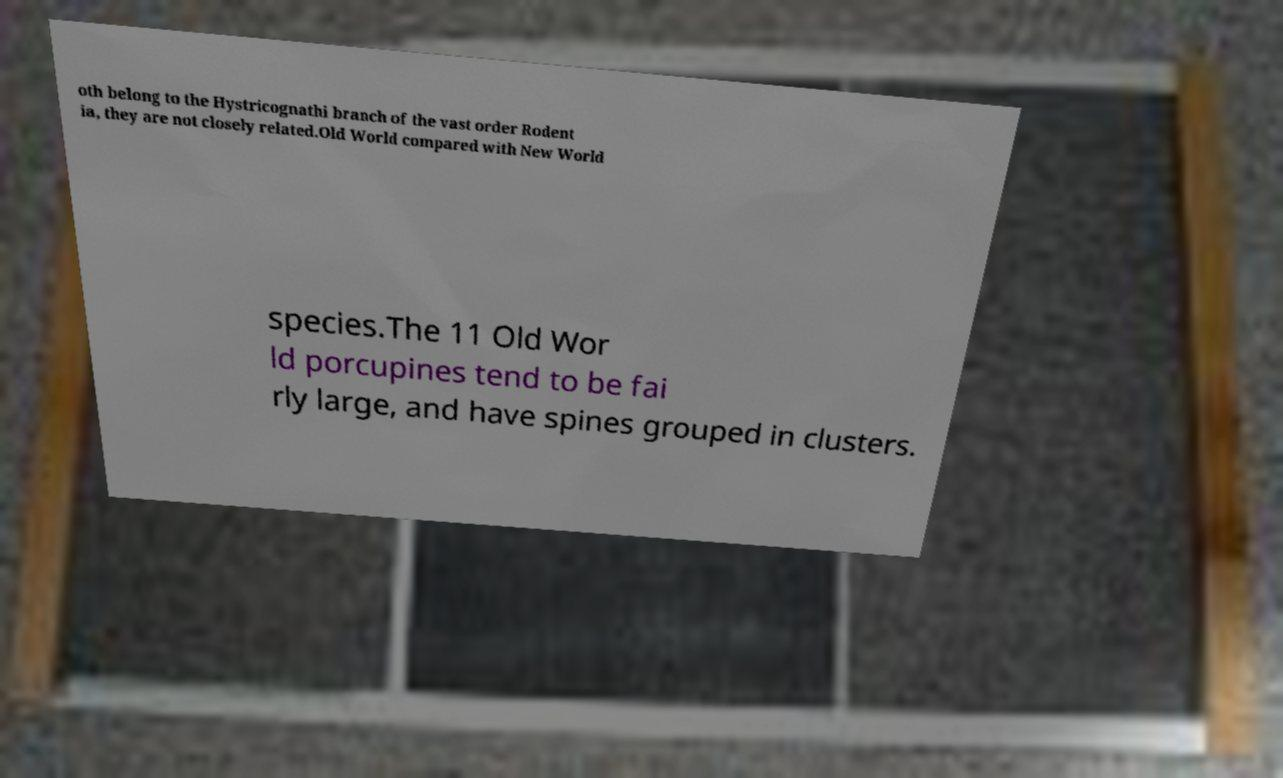What messages or text are displayed in this image? I need them in a readable, typed format. oth belong to the Hystricognathi branch of the vast order Rodent ia, they are not closely related.Old World compared with New World species.The 11 Old Wor ld porcupines tend to be fai rly large, and have spines grouped in clusters. 